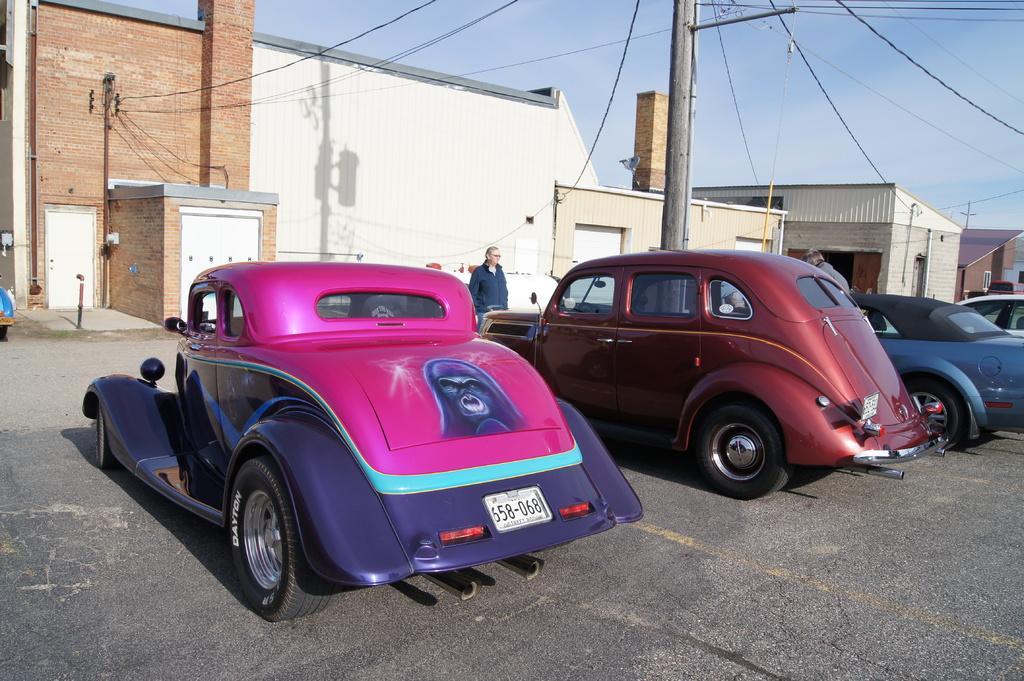In one or two sentences, can you explain what this image depicts? In this image, there are a few people and vehicles. We can see the ground. There are a few poles with wires. There are a few houses. We can also see the shadow of a pole with an object on one of the houses. We can see the sky. 